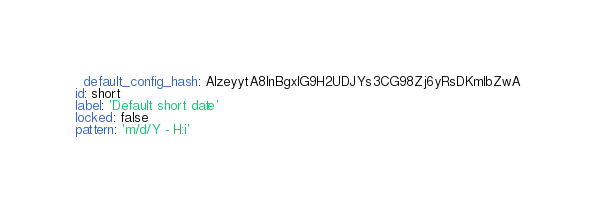Convert code to text. <code><loc_0><loc_0><loc_500><loc_500><_YAML_>  default_config_hash: AlzeyytA8InBgxIG9H2UDJYs3CG98Zj6yRsDKmlbZwA
id: short
label: 'Default short date'
locked: false
pattern: 'm/d/Y - H:i'
</code> 